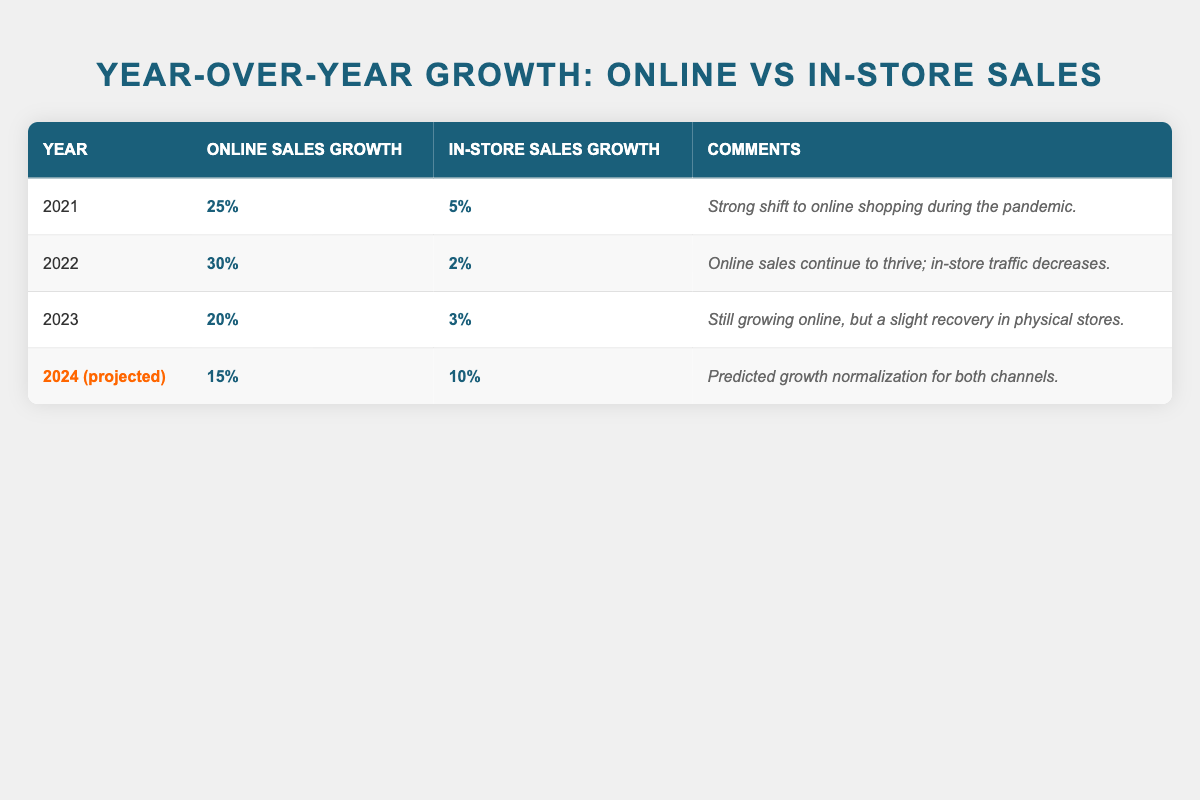What was the online sales growth in 2022? The table shows that the online sales growth in 2022 is listed as 30%.
Answer: 30% What year saw the highest in-store sales growth? Looking at the table, in-store sales growth is 5% in 2021, 2% in 2022, 3% in 2023, and 10% projected for 2024. The highest is 10% in the projected year 2024.
Answer: 10% What is the difference in online sales growth between 2021 and 2023? For 2021, the online sales growth is 25% and for 2023, it is 20%. The difference is calculated as 25% - 20% = 5%.
Answer: 5% Is the in-store sales growth decreasing over the years? In-store sales growth is 5% in 2021, decreases to 2% in 2022, and then rises slightly to 3% in 2023. So, it is not consistently decreasing.
Answer: No Was there a stronger recovery in online sales or in-store sales by 2023? Online sales grew by 20% in 2023 but in-store sales grew only by 3%. Therefore, the stronger recovery is in online sales.
Answer: Online sales What is the projected total growth rate for online and in-store sales in 2024? The projected online sales growth for 2024 is 15% and in-store sales growth is 10%. Adding these together gives a total growth rate of 15% + 10% = 25%.
Answer: 25% Did online sales growth peak in 2022? By comparing years, the online sales growth was 25% in 2021, peaked at 30% in 2022, and then decreased to 20% in 2023. Hence, it did peak in 2022.
Answer: Yes Which year experienced the most significant decline in online sales growth compared to the previous year? From 2021 (25%) to 2022 (30%) there was an increase, but from 2022 (30%) to 2023 (20%) there was a decline of 10%, which is the largest decline.
Answer: 2022 to 2023 What will be the approximate average online sales growth over the four years provided? The online sales growths are 25%, 30%, 20%, and 15%. Summing those gives 25 + 30 + 20 + 15 = 90, and averaging them by dividing by 4 gives 90 / 4 = 22.5%.
Answer: 22.5% 